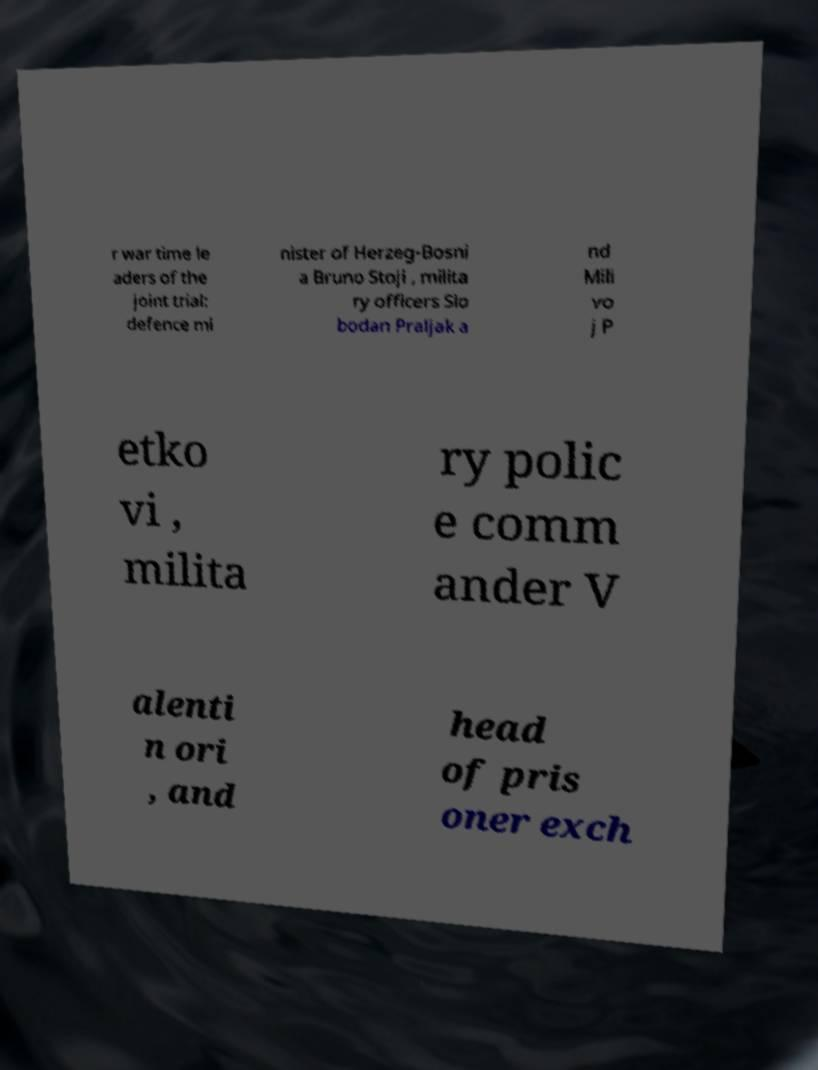For documentation purposes, I need the text within this image transcribed. Could you provide that? r war time le aders of the joint trial: defence mi nister of Herzeg-Bosni a Bruno Stoji , milita ry officers Slo bodan Praljak a nd Mili vo j P etko vi , milita ry polic e comm ander V alenti n ori , and head of pris oner exch 